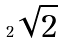<formula> <loc_0><loc_0><loc_500><loc_500>2 \sqrt { 2 }</formula> 